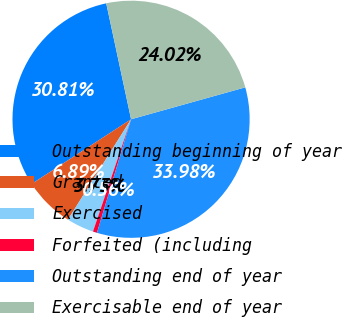Convert chart. <chart><loc_0><loc_0><loc_500><loc_500><pie_chart><fcel>Outstanding beginning of year<fcel>Granted<fcel>Exercised<fcel>Forfeited (including<fcel>Outstanding end of year<fcel>Exercisable end of year<nl><fcel>30.81%<fcel>6.89%<fcel>3.73%<fcel>0.56%<fcel>33.98%<fcel>24.02%<nl></chart> 